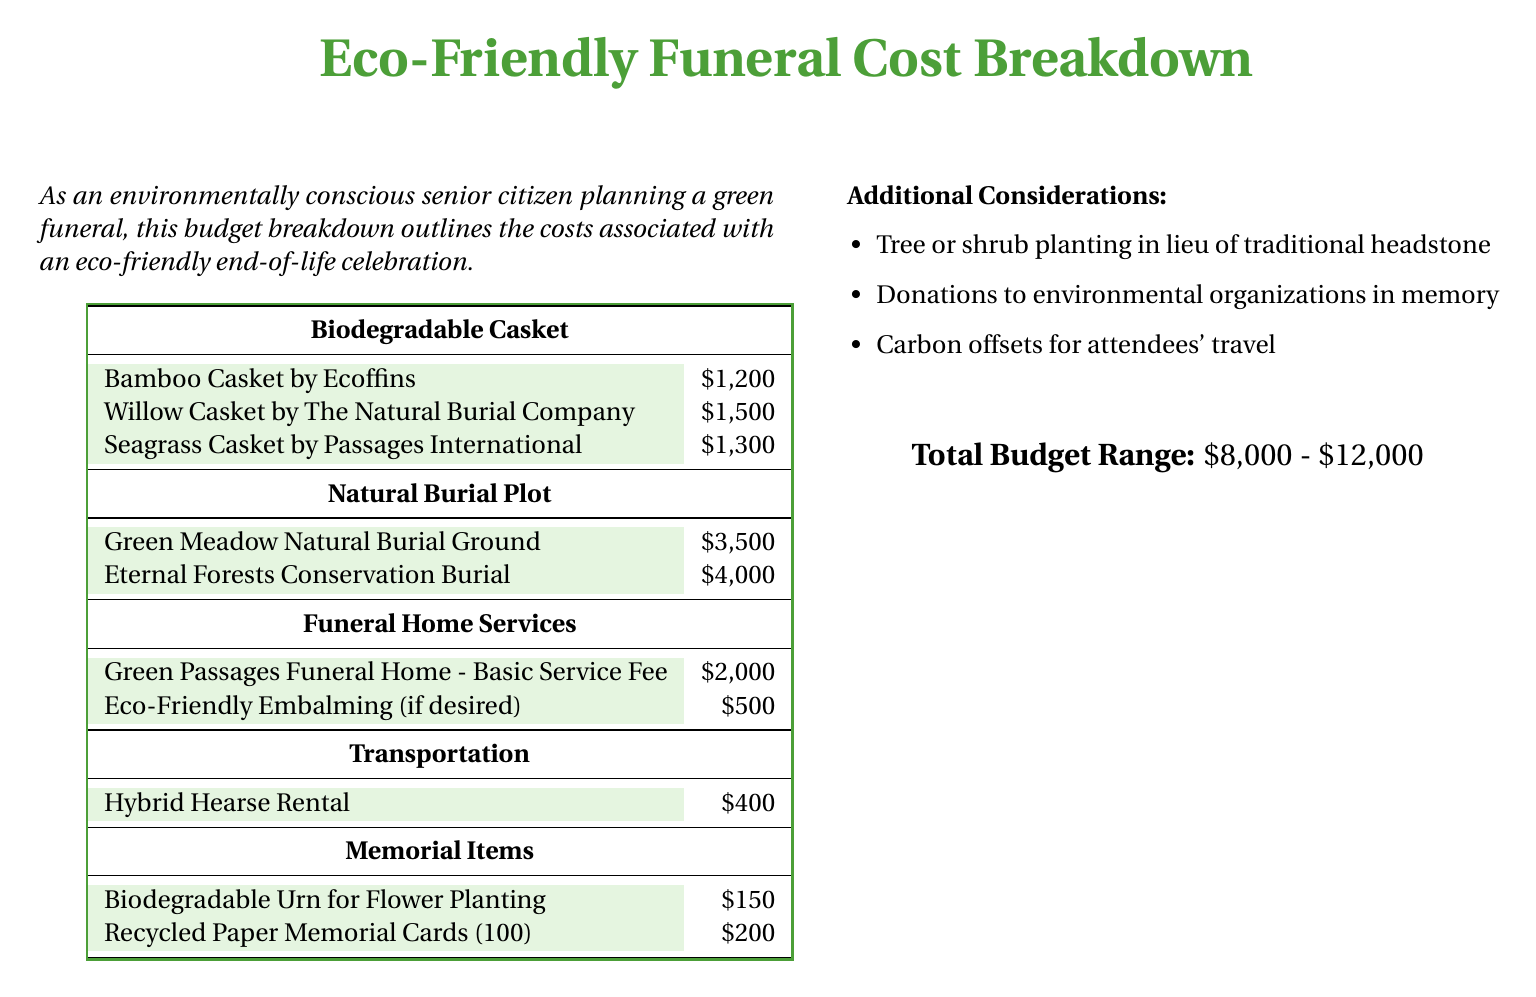What is the cost of a Willow Casket? The cost of a Willow Casket by The Natural Burial Company is specifically listed in the document.
Answer: $1,500 What is the lowest cost for a Natural Burial Plot? The document provides a list of Natural Burial Plots with their respective prices; the lowest one is highlighted.
Answer: $3,500 What is the cost of Eco-Friendly Embalming? The cost of Eco-Friendly Embalming is mentioned in the section about Funeral Home Services in the document.
Answer: $500 What is the total budget range for an eco-friendly funeral? The total budget range is stated at the bottom of the document, summarizing the expected costs for the whole funeral process.
Answer: $8,000 - $12,000 How much does a Biodegradable Urn for Flower Planting cost? This specific item is listed with its associated cost in the Memorial Items section.
Answer: $150 What type of vehicle is used for transportation? The document mentions a specific type of vehicle for transportation under the Transportation section.
Answer: Hybrid Hearse How many Recycled Paper Memorial Cards can you get for $200? The document states the quantity of the paper memorial cards available for that price.
Answer: 100 Which funeral home offers a basic service fee of $2,000? The specific funeral home with this basic service fee is mentioned in the Funeral Home Services section.
Answer: Green Passages Funeral Home What alternative does the document suggest instead of a traditional headstone? The document includes additional considerations for eco-friendly alternatives to traditional headstones.
Answer: Tree or shrub planting 